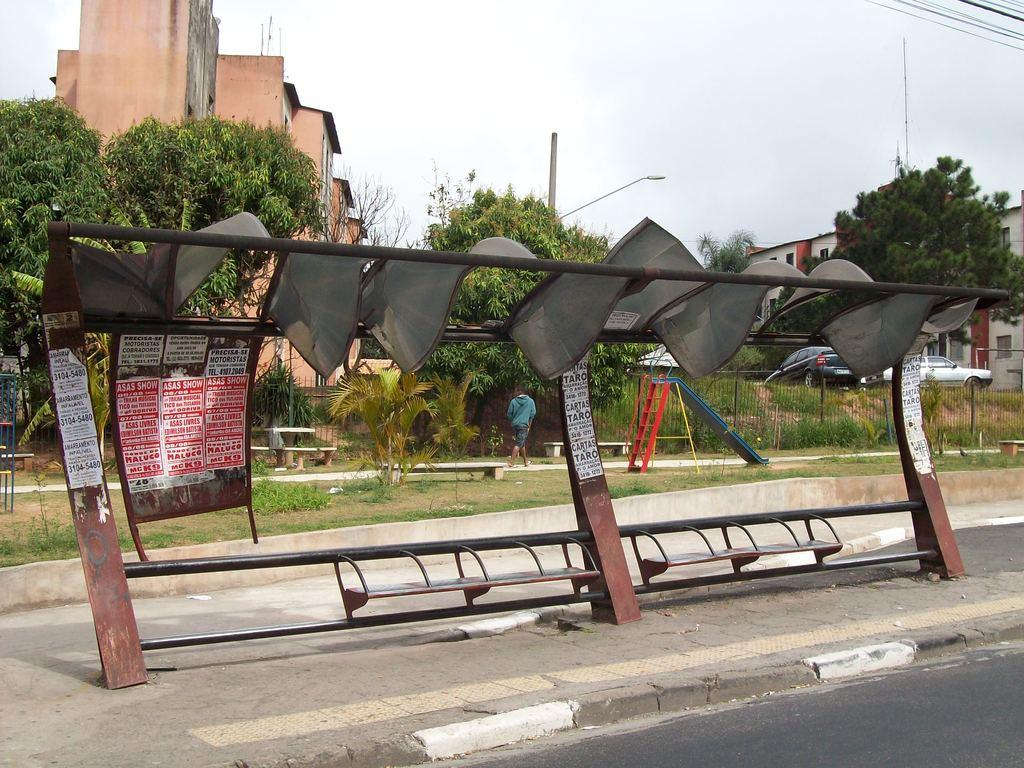What is the main subject in the image? There is a bus stop in the image. What can be seen in the background of the image? There is a playground, trees, and buildings in the background of the image. Can you see a hydrant near the bus stop in the image? There is no hydrant visible near the bus stop in the image. What type of snail can be seen crawling on the chin of the person at the bus stop? There is no person or snail present at the bus stop in the image. 